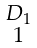<formula> <loc_0><loc_0><loc_500><loc_500>\begin{smallmatrix} D _ { 1 } \\ 1 \end{smallmatrix}</formula> 